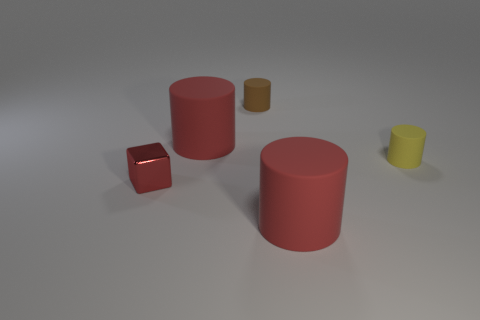There is a rubber thing in front of the tiny yellow object; how big is it?
Keep it short and to the point. Large. Is there a yellow shiny cube of the same size as the red shiny cube?
Give a very brief answer. No. How many objects are either rubber cylinders in front of the tiny brown rubber cylinder or small yellow matte things?
Your response must be concise. 3. Is the material of the yellow thing the same as the object that is in front of the small red metal thing?
Give a very brief answer. Yes. How many other objects are there of the same shape as the small yellow matte object?
Offer a terse response. 3. How many things are either big cylinders left of the tiny brown rubber object or red rubber cylinders behind the metallic object?
Give a very brief answer. 1. How many other things are there of the same color as the block?
Provide a succinct answer. 2. Is the number of tiny brown matte objects that are behind the red shiny thing less than the number of large red things in front of the small brown object?
Your answer should be compact. Yes. What number of small rubber things are there?
Provide a short and direct response. 2. Is there anything else that has the same material as the red cube?
Provide a succinct answer. No. 